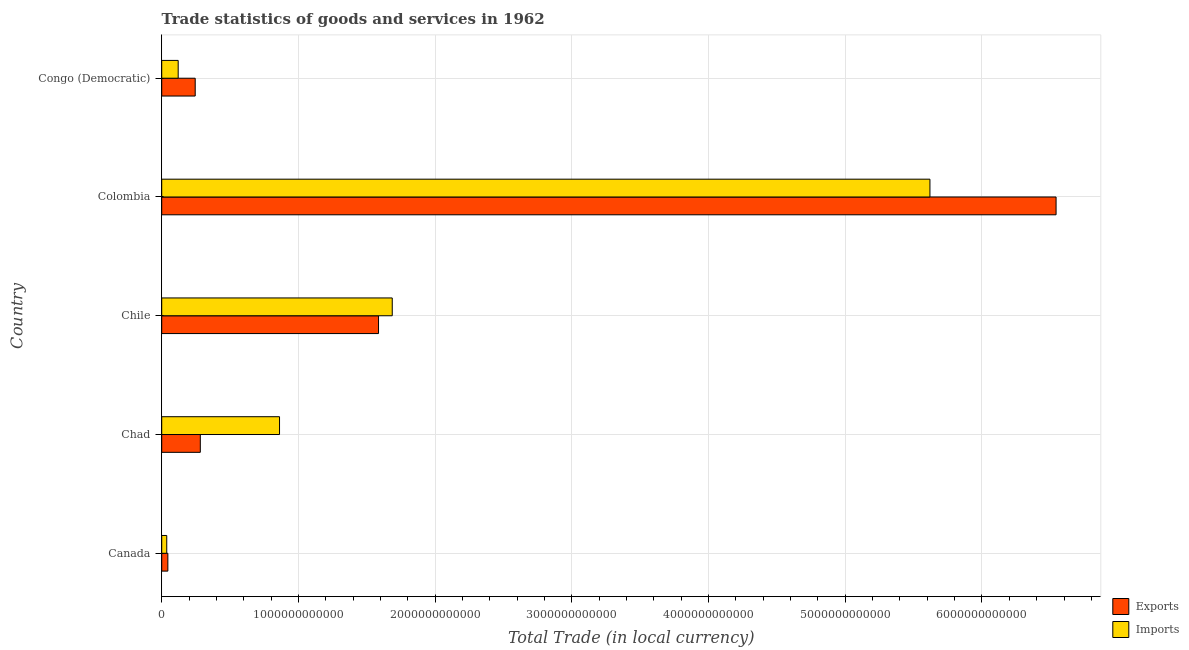How many groups of bars are there?
Make the answer very short. 5. Are the number of bars per tick equal to the number of legend labels?
Your response must be concise. Yes. Are the number of bars on each tick of the Y-axis equal?
Your response must be concise. Yes. How many bars are there on the 3rd tick from the top?
Your answer should be very brief. 2. What is the label of the 4th group of bars from the top?
Offer a very short reply. Chad. In how many cases, is the number of bars for a given country not equal to the number of legend labels?
Provide a succinct answer. 0. What is the export of goods and services in Canada?
Your answer should be very brief. 4.49e+1. Across all countries, what is the maximum imports of goods and services?
Make the answer very short. 5.62e+12. Across all countries, what is the minimum imports of goods and services?
Your response must be concise. 3.69e+1. In which country was the imports of goods and services minimum?
Provide a succinct answer. Canada. What is the total export of goods and services in the graph?
Your answer should be very brief. 8.70e+12. What is the difference between the imports of goods and services in Canada and that in Congo (Democratic)?
Ensure brevity in your answer.  -8.36e+1. What is the difference between the export of goods and services in Colombia and the imports of goods and services in Chad?
Offer a terse response. 5.68e+12. What is the average imports of goods and services per country?
Keep it short and to the point. 1.66e+12. What is the difference between the imports of goods and services and export of goods and services in Colombia?
Ensure brevity in your answer.  -9.23e+11. What is the ratio of the imports of goods and services in Canada to that in Congo (Democratic)?
Make the answer very short. 0.31. What is the difference between the highest and the second highest export of goods and services?
Ensure brevity in your answer.  4.96e+12. What is the difference between the highest and the lowest export of goods and services?
Make the answer very short. 6.50e+12. What does the 1st bar from the top in Chad represents?
Ensure brevity in your answer.  Imports. What does the 1st bar from the bottom in Canada represents?
Make the answer very short. Exports. How many bars are there?
Your answer should be very brief. 10. Are all the bars in the graph horizontal?
Your answer should be compact. Yes. What is the difference between two consecutive major ticks on the X-axis?
Offer a terse response. 1.00e+12. Where does the legend appear in the graph?
Offer a very short reply. Bottom right. How many legend labels are there?
Provide a short and direct response. 2. How are the legend labels stacked?
Ensure brevity in your answer.  Vertical. What is the title of the graph?
Ensure brevity in your answer.  Trade statistics of goods and services in 1962. Does "Malaria" appear as one of the legend labels in the graph?
Your answer should be compact. No. What is the label or title of the X-axis?
Offer a terse response. Total Trade (in local currency). What is the label or title of the Y-axis?
Offer a terse response. Country. What is the Total Trade (in local currency) of Exports in Canada?
Ensure brevity in your answer.  4.49e+1. What is the Total Trade (in local currency) in Imports in Canada?
Provide a short and direct response. 3.69e+1. What is the Total Trade (in local currency) in Exports in Chad?
Give a very brief answer. 2.82e+11. What is the Total Trade (in local currency) in Imports in Chad?
Provide a succinct answer. 8.62e+11. What is the Total Trade (in local currency) in Exports in Chile?
Keep it short and to the point. 1.59e+12. What is the Total Trade (in local currency) of Imports in Chile?
Make the answer very short. 1.69e+12. What is the Total Trade (in local currency) of Exports in Colombia?
Your answer should be compact. 6.54e+12. What is the Total Trade (in local currency) in Imports in Colombia?
Ensure brevity in your answer.  5.62e+12. What is the Total Trade (in local currency) of Exports in Congo (Democratic)?
Provide a short and direct response. 2.45e+11. What is the Total Trade (in local currency) in Imports in Congo (Democratic)?
Your answer should be very brief. 1.20e+11. Across all countries, what is the maximum Total Trade (in local currency) in Exports?
Provide a succinct answer. 6.54e+12. Across all countries, what is the maximum Total Trade (in local currency) of Imports?
Your answer should be very brief. 5.62e+12. Across all countries, what is the minimum Total Trade (in local currency) in Exports?
Your response must be concise. 4.49e+1. Across all countries, what is the minimum Total Trade (in local currency) in Imports?
Give a very brief answer. 3.69e+1. What is the total Total Trade (in local currency) of Exports in the graph?
Your answer should be very brief. 8.70e+12. What is the total Total Trade (in local currency) of Imports in the graph?
Provide a succinct answer. 8.32e+12. What is the difference between the Total Trade (in local currency) in Exports in Canada and that in Chad?
Keep it short and to the point. -2.37e+11. What is the difference between the Total Trade (in local currency) in Imports in Canada and that in Chad?
Keep it short and to the point. -8.25e+11. What is the difference between the Total Trade (in local currency) of Exports in Canada and that in Chile?
Give a very brief answer. -1.54e+12. What is the difference between the Total Trade (in local currency) in Imports in Canada and that in Chile?
Offer a very short reply. -1.65e+12. What is the difference between the Total Trade (in local currency) of Exports in Canada and that in Colombia?
Offer a very short reply. -6.50e+12. What is the difference between the Total Trade (in local currency) of Imports in Canada and that in Colombia?
Your response must be concise. -5.58e+12. What is the difference between the Total Trade (in local currency) in Exports in Canada and that in Congo (Democratic)?
Offer a terse response. -2.00e+11. What is the difference between the Total Trade (in local currency) in Imports in Canada and that in Congo (Democratic)?
Offer a terse response. -8.36e+1. What is the difference between the Total Trade (in local currency) of Exports in Chad and that in Chile?
Your response must be concise. -1.30e+12. What is the difference between the Total Trade (in local currency) in Imports in Chad and that in Chile?
Your response must be concise. -8.24e+11. What is the difference between the Total Trade (in local currency) of Exports in Chad and that in Colombia?
Provide a succinct answer. -6.26e+12. What is the difference between the Total Trade (in local currency) of Imports in Chad and that in Colombia?
Provide a short and direct response. -4.76e+12. What is the difference between the Total Trade (in local currency) of Exports in Chad and that in Congo (Democratic)?
Provide a short and direct response. 3.73e+1. What is the difference between the Total Trade (in local currency) of Imports in Chad and that in Congo (Democratic)?
Keep it short and to the point. 7.41e+11. What is the difference between the Total Trade (in local currency) in Exports in Chile and that in Colombia?
Your response must be concise. -4.96e+12. What is the difference between the Total Trade (in local currency) of Imports in Chile and that in Colombia?
Your response must be concise. -3.93e+12. What is the difference between the Total Trade (in local currency) of Exports in Chile and that in Congo (Democratic)?
Your answer should be compact. 1.34e+12. What is the difference between the Total Trade (in local currency) in Imports in Chile and that in Congo (Democratic)?
Provide a succinct answer. 1.57e+12. What is the difference between the Total Trade (in local currency) in Exports in Colombia and that in Congo (Democratic)?
Keep it short and to the point. 6.30e+12. What is the difference between the Total Trade (in local currency) of Imports in Colombia and that in Congo (Democratic)?
Give a very brief answer. 5.50e+12. What is the difference between the Total Trade (in local currency) in Exports in Canada and the Total Trade (in local currency) in Imports in Chad?
Your answer should be very brief. -8.17e+11. What is the difference between the Total Trade (in local currency) in Exports in Canada and the Total Trade (in local currency) in Imports in Chile?
Provide a succinct answer. -1.64e+12. What is the difference between the Total Trade (in local currency) in Exports in Canada and the Total Trade (in local currency) in Imports in Colombia?
Your answer should be compact. -5.57e+12. What is the difference between the Total Trade (in local currency) in Exports in Canada and the Total Trade (in local currency) in Imports in Congo (Democratic)?
Keep it short and to the point. -7.56e+1. What is the difference between the Total Trade (in local currency) of Exports in Chad and the Total Trade (in local currency) of Imports in Chile?
Ensure brevity in your answer.  -1.40e+12. What is the difference between the Total Trade (in local currency) of Exports in Chad and the Total Trade (in local currency) of Imports in Colombia?
Make the answer very short. -5.34e+12. What is the difference between the Total Trade (in local currency) of Exports in Chad and the Total Trade (in local currency) of Imports in Congo (Democratic)?
Ensure brevity in your answer.  1.62e+11. What is the difference between the Total Trade (in local currency) of Exports in Chile and the Total Trade (in local currency) of Imports in Colombia?
Provide a succinct answer. -4.03e+12. What is the difference between the Total Trade (in local currency) of Exports in Chile and the Total Trade (in local currency) of Imports in Congo (Democratic)?
Offer a terse response. 1.47e+12. What is the difference between the Total Trade (in local currency) of Exports in Colombia and the Total Trade (in local currency) of Imports in Congo (Democratic)?
Your answer should be very brief. 6.42e+12. What is the average Total Trade (in local currency) of Exports per country?
Provide a succinct answer. 1.74e+12. What is the average Total Trade (in local currency) in Imports per country?
Your answer should be very brief. 1.66e+12. What is the difference between the Total Trade (in local currency) in Exports and Total Trade (in local currency) in Imports in Canada?
Keep it short and to the point. 8.01e+09. What is the difference between the Total Trade (in local currency) of Exports and Total Trade (in local currency) of Imports in Chad?
Offer a very short reply. -5.80e+11. What is the difference between the Total Trade (in local currency) in Exports and Total Trade (in local currency) in Imports in Chile?
Your response must be concise. -1.00e+11. What is the difference between the Total Trade (in local currency) in Exports and Total Trade (in local currency) in Imports in Colombia?
Your answer should be very brief. 9.23e+11. What is the difference between the Total Trade (in local currency) in Exports and Total Trade (in local currency) in Imports in Congo (Democratic)?
Make the answer very short. 1.25e+11. What is the ratio of the Total Trade (in local currency) of Exports in Canada to that in Chad?
Provide a succinct answer. 0.16. What is the ratio of the Total Trade (in local currency) in Imports in Canada to that in Chad?
Ensure brevity in your answer.  0.04. What is the ratio of the Total Trade (in local currency) in Exports in Canada to that in Chile?
Offer a very short reply. 0.03. What is the ratio of the Total Trade (in local currency) in Imports in Canada to that in Chile?
Your answer should be compact. 0.02. What is the ratio of the Total Trade (in local currency) in Exports in Canada to that in Colombia?
Your answer should be compact. 0.01. What is the ratio of the Total Trade (in local currency) of Imports in Canada to that in Colombia?
Make the answer very short. 0.01. What is the ratio of the Total Trade (in local currency) of Exports in Canada to that in Congo (Democratic)?
Make the answer very short. 0.18. What is the ratio of the Total Trade (in local currency) of Imports in Canada to that in Congo (Democratic)?
Your answer should be compact. 0.31. What is the ratio of the Total Trade (in local currency) of Exports in Chad to that in Chile?
Keep it short and to the point. 0.18. What is the ratio of the Total Trade (in local currency) in Imports in Chad to that in Chile?
Offer a very short reply. 0.51. What is the ratio of the Total Trade (in local currency) of Exports in Chad to that in Colombia?
Offer a very short reply. 0.04. What is the ratio of the Total Trade (in local currency) of Imports in Chad to that in Colombia?
Offer a terse response. 0.15. What is the ratio of the Total Trade (in local currency) of Exports in Chad to that in Congo (Democratic)?
Give a very brief answer. 1.15. What is the ratio of the Total Trade (in local currency) of Imports in Chad to that in Congo (Democratic)?
Offer a very short reply. 7.15. What is the ratio of the Total Trade (in local currency) in Exports in Chile to that in Colombia?
Ensure brevity in your answer.  0.24. What is the ratio of the Total Trade (in local currency) in Imports in Chile to that in Colombia?
Offer a very short reply. 0.3. What is the ratio of the Total Trade (in local currency) in Exports in Chile to that in Congo (Democratic)?
Your answer should be compact. 6.47. What is the ratio of the Total Trade (in local currency) in Imports in Chile to that in Congo (Democratic)?
Provide a short and direct response. 14. What is the ratio of the Total Trade (in local currency) in Exports in Colombia to that in Congo (Democratic)?
Make the answer very short. 26.7. What is the ratio of the Total Trade (in local currency) of Imports in Colombia to that in Congo (Democratic)?
Make the answer very short. 46.63. What is the difference between the highest and the second highest Total Trade (in local currency) in Exports?
Your answer should be very brief. 4.96e+12. What is the difference between the highest and the second highest Total Trade (in local currency) in Imports?
Offer a terse response. 3.93e+12. What is the difference between the highest and the lowest Total Trade (in local currency) in Exports?
Your answer should be very brief. 6.50e+12. What is the difference between the highest and the lowest Total Trade (in local currency) of Imports?
Your answer should be very brief. 5.58e+12. 